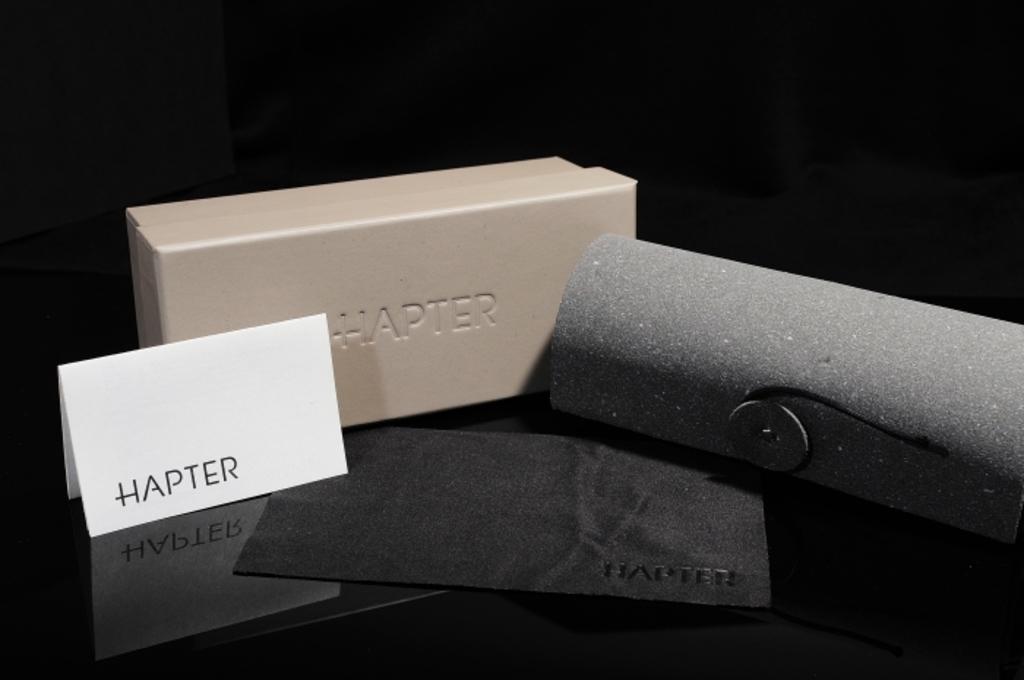Brand name of this?
Give a very brief answer. Hapter. 